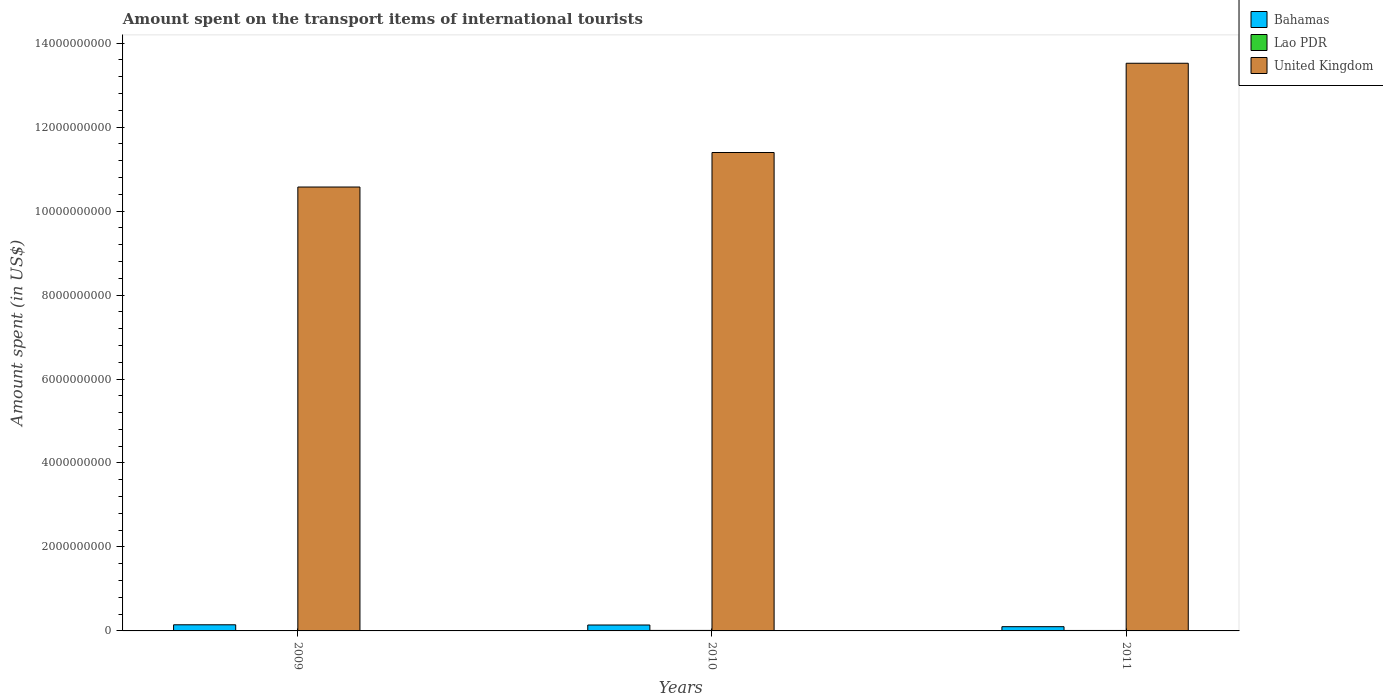How many bars are there on the 1st tick from the right?
Make the answer very short. 3. What is the label of the 3rd group of bars from the left?
Give a very brief answer. 2011. What is the amount spent on the transport items of international tourists in Bahamas in 2009?
Ensure brevity in your answer.  1.46e+08. Across all years, what is the maximum amount spent on the transport items of international tourists in United Kingdom?
Your answer should be very brief. 1.35e+1. Across all years, what is the minimum amount spent on the transport items of international tourists in Bahamas?
Make the answer very short. 1.01e+08. In which year was the amount spent on the transport items of international tourists in Lao PDR maximum?
Offer a terse response. 2010. What is the total amount spent on the transport items of international tourists in Bahamas in the graph?
Your answer should be compact. 3.88e+08. What is the difference between the amount spent on the transport items of international tourists in Lao PDR in 2009 and that in 2011?
Provide a short and direct response. -3.00e+06. What is the difference between the amount spent on the transport items of international tourists in Lao PDR in 2010 and the amount spent on the transport items of international tourists in United Kingdom in 2009?
Offer a very short reply. -1.06e+1. What is the average amount spent on the transport items of international tourists in United Kingdom per year?
Ensure brevity in your answer.  1.18e+1. In the year 2009, what is the difference between the amount spent on the transport items of international tourists in United Kingdom and amount spent on the transport items of international tourists in Bahamas?
Offer a very short reply. 1.04e+1. What is the ratio of the amount spent on the transport items of international tourists in United Kingdom in 2009 to that in 2010?
Provide a succinct answer. 0.93. Is the amount spent on the transport items of international tourists in Bahamas in 2009 less than that in 2010?
Give a very brief answer. No. What is the difference between the highest and the second highest amount spent on the transport items of international tourists in United Kingdom?
Give a very brief answer. 2.13e+09. What is the difference between the highest and the lowest amount spent on the transport items of international tourists in Bahamas?
Make the answer very short. 4.50e+07. In how many years, is the amount spent on the transport items of international tourists in United Kingdom greater than the average amount spent on the transport items of international tourists in United Kingdom taken over all years?
Your answer should be very brief. 1. Is the sum of the amount spent on the transport items of international tourists in Bahamas in 2009 and 2011 greater than the maximum amount spent on the transport items of international tourists in Lao PDR across all years?
Offer a very short reply. Yes. What does the 2nd bar from the left in 2010 represents?
Your response must be concise. Lao PDR. What does the 2nd bar from the right in 2011 represents?
Provide a short and direct response. Lao PDR. Is it the case that in every year, the sum of the amount spent on the transport items of international tourists in United Kingdom and amount spent on the transport items of international tourists in Bahamas is greater than the amount spent on the transport items of international tourists in Lao PDR?
Provide a succinct answer. Yes. How many bars are there?
Keep it short and to the point. 9. Are all the bars in the graph horizontal?
Your answer should be compact. No. How many years are there in the graph?
Provide a succinct answer. 3. Does the graph contain any zero values?
Your response must be concise. No. Where does the legend appear in the graph?
Ensure brevity in your answer.  Top right. How are the legend labels stacked?
Your answer should be compact. Vertical. What is the title of the graph?
Keep it short and to the point. Amount spent on the transport items of international tourists. Does "Ethiopia" appear as one of the legend labels in the graph?
Your answer should be very brief. No. What is the label or title of the Y-axis?
Give a very brief answer. Amount spent (in US$). What is the Amount spent (in US$) of Bahamas in 2009?
Your response must be concise. 1.46e+08. What is the Amount spent (in US$) of United Kingdom in 2009?
Provide a succinct answer. 1.06e+1. What is the Amount spent (in US$) of Bahamas in 2010?
Provide a short and direct response. 1.41e+08. What is the Amount spent (in US$) in Lao PDR in 2010?
Keep it short and to the point. 1.20e+07. What is the Amount spent (in US$) in United Kingdom in 2010?
Give a very brief answer. 1.14e+1. What is the Amount spent (in US$) of Bahamas in 2011?
Provide a short and direct response. 1.01e+08. What is the Amount spent (in US$) in Lao PDR in 2011?
Ensure brevity in your answer.  1.10e+07. What is the Amount spent (in US$) in United Kingdom in 2011?
Offer a terse response. 1.35e+1. Across all years, what is the maximum Amount spent (in US$) in Bahamas?
Offer a terse response. 1.46e+08. Across all years, what is the maximum Amount spent (in US$) of United Kingdom?
Ensure brevity in your answer.  1.35e+1. Across all years, what is the minimum Amount spent (in US$) of Bahamas?
Make the answer very short. 1.01e+08. Across all years, what is the minimum Amount spent (in US$) of Lao PDR?
Provide a short and direct response. 8.00e+06. Across all years, what is the minimum Amount spent (in US$) of United Kingdom?
Make the answer very short. 1.06e+1. What is the total Amount spent (in US$) in Bahamas in the graph?
Your answer should be compact. 3.88e+08. What is the total Amount spent (in US$) in Lao PDR in the graph?
Provide a short and direct response. 3.10e+07. What is the total Amount spent (in US$) in United Kingdom in the graph?
Provide a short and direct response. 3.55e+1. What is the difference between the Amount spent (in US$) in Lao PDR in 2009 and that in 2010?
Give a very brief answer. -4.00e+06. What is the difference between the Amount spent (in US$) of United Kingdom in 2009 and that in 2010?
Offer a terse response. -8.22e+08. What is the difference between the Amount spent (in US$) in Bahamas in 2009 and that in 2011?
Give a very brief answer. 4.50e+07. What is the difference between the Amount spent (in US$) of Lao PDR in 2009 and that in 2011?
Offer a very short reply. -3.00e+06. What is the difference between the Amount spent (in US$) in United Kingdom in 2009 and that in 2011?
Your answer should be very brief. -2.95e+09. What is the difference between the Amount spent (in US$) of Bahamas in 2010 and that in 2011?
Give a very brief answer. 4.00e+07. What is the difference between the Amount spent (in US$) in United Kingdom in 2010 and that in 2011?
Your answer should be compact. -2.13e+09. What is the difference between the Amount spent (in US$) of Bahamas in 2009 and the Amount spent (in US$) of Lao PDR in 2010?
Provide a short and direct response. 1.34e+08. What is the difference between the Amount spent (in US$) in Bahamas in 2009 and the Amount spent (in US$) in United Kingdom in 2010?
Keep it short and to the point. -1.12e+1. What is the difference between the Amount spent (in US$) in Lao PDR in 2009 and the Amount spent (in US$) in United Kingdom in 2010?
Your response must be concise. -1.14e+1. What is the difference between the Amount spent (in US$) of Bahamas in 2009 and the Amount spent (in US$) of Lao PDR in 2011?
Give a very brief answer. 1.35e+08. What is the difference between the Amount spent (in US$) in Bahamas in 2009 and the Amount spent (in US$) in United Kingdom in 2011?
Give a very brief answer. -1.34e+1. What is the difference between the Amount spent (in US$) in Lao PDR in 2009 and the Amount spent (in US$) in United Kingdom in 2011?
Ensure brevity in your answer.  -1.35e+1. What is the difference between the Amount spent (in US$) of Bahamas in 2010 and the Amount spent (in US$) of Lao PDR in 2011?
Your answer should be very brief. 1.30e+08. What is the difference between the Amount spent (in US$) of Bahamas in 2010 and the Amount spent (in US$) of United Kingdom in 2011?
Make the answer very short. -1.34e+1. What is the difference between the Amount spent (in US$) of Lao PDR in 2010 and the Amount spent (in US$) of United Kingdom in 2011?
Give a very brief answer. -1.35e+1. What is the average Amount spent (in US$) of Bahamas per year?
Make the answer very short. 1.29e+08. What is the average Amount spent (in US$) of Lao PDR per year?
Ensure brevity in your answer.  1.03e+07. What is the average Amount spent (in US$) in United Kingdom per year?
Provide a succinct answer. 1.18e+1. In the year 2009, what is the difference between the Amount spent (in US$) in Bahamas and Amount spent (in US$) in Lao PDR?
Offer a very short reply. 1.38e+08. In the year 2009, what is the difference between the Amount spent (in US$) in Bahamas and Amount spent (in US$) in United Kingdom?
Offer a very short reply. -1.04e+1. In the year 2009, what is the difference between the Amount spent (in US$) in Lao PDR and Amount spent (in US$) in United Kingdom?
Ensure brevity in your answer.  -1.06e+1. In the year 2010, what is the difference between the Amount spent (in US$) in Bahamas and Amount spent (in US$) in Lao PDR?
Make the answer very short. 1.29e+08. In the year 2010, what is the difference between the Amount spent (in US$) in Bahamas and Amount spent (in US$) in United Kingdom?
Keep it short and to the point. -1.13e+1. In the year 2010, what is the difference between the Amount spent (in US$) in Lao PDR and Amount spent (in US$) in United Kingdom?
Ensure brevity in your answer.  -1.14e+1. In the year 2011, what is the difference between the Amount spent (in US$) of Bahamas and Amount spent (in US$) of Lao PDR?
Your answer should be very brief. 9.00e+07. In the year 2011, what is the difference between the Amount spent (in US$) in Bahamas and Amount spent (in US$) in United Kingdom?
Your answer should be very brief. -1.34e+1. In the year 2011, what is the difference between the Amount spent (in US$) in Lao PDR and Amount spent (in US$) in United Kingdom?
Ensure brevity in your answer.  -1.35e+1. What is the ratio of the Amount spent (in US$) of Bahamas in 2009 to that in 2010?
Provide a short and direct response. 1.04. What is the ratio of the Amount spent (in US$) in United Kingdom in 2009 to that in 2010?
Ensure brevity in your answer.  0.93. What is the ratio of the Amount spent (in US$) of Bahamas in 2009 to that in 2011?
Keep it short and to the point. 1.45. What is the ratio of the Amount spent (in US$) of Lao PDR in 2009 to that in 2011?
Your answer should be compact. 0.73. What is the ratio of the Amount spent (in US$) of United Kingdom in 2009 to that in 2011?
Give a very brief answer. 0.78. What is the ratio of the Amount spent (in US$) of Bahamas in 2010 to that in 2011?
Ensure brevity in your answer.  1.4. What is the ratio of the Amount spent (in US$) of United Kingdom in 2010 to that in 2011?
Ensure brevity in your answer.  0.84. What is the difference between the highest and the second highest Amount spent (in US$) in Bahamas?
Offer a very short reply. 5.00e+06. What is the difference between the highest and the second highest Amount spent (in US$) in Lao PDR?
Offer a terse response. 1.00e+06. What is the difference between the highest and the second highest Amount spent (in US$) of United Kingdom?
Offer a terse response. 2.13e+09. What is the difference between the highest and the lowest Amount spent (in US$) in Bahamas?
Provide a succinct answer. 4.50e+07. What is the difference between the highest and the lowest Amount spent (in US$) in Lao PDR?
Give a very brief answer. 4.00e+06. What is the difference between the highest and the lowest Amount spent (in US$) of United Kingdom?
Offer a very short reply. 2.95e+09. 